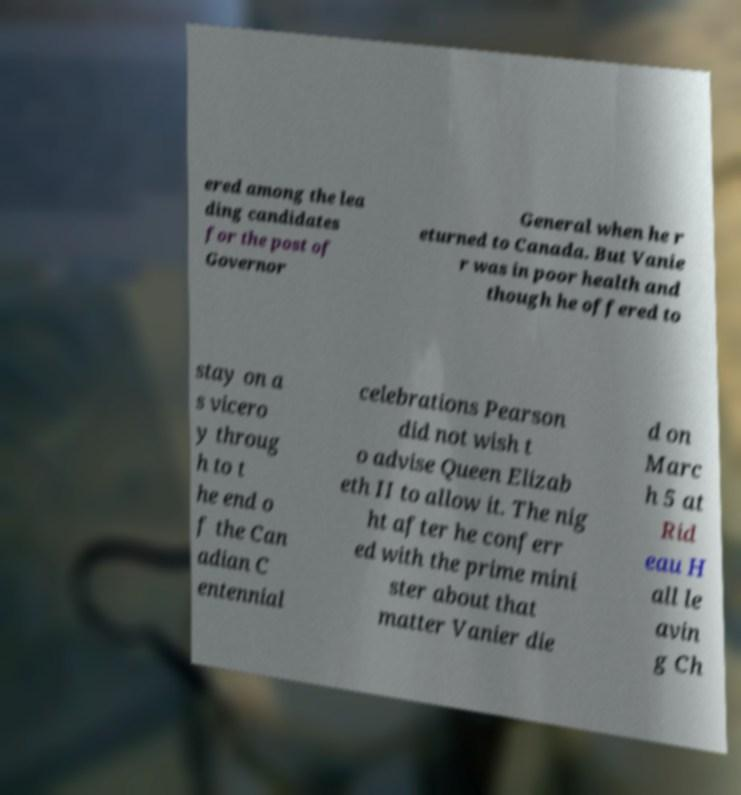Can you accurately transcribe the text from the provided image for me? ered among the lea ding candidates for the post of Governor General when he r eturned to Canada. But Vanie r was in poor health and though he offered to stay on a s vicero y throug h to t he end o f the Can adian C entennial celebrations Pearson did not wish t o advise Queen Elizab eth II to allow it. The nig ht after he conferr ed with the prime mini ster about that matter Vanier die d on Marc h 5 at Rid eau H all le avin g Ch 